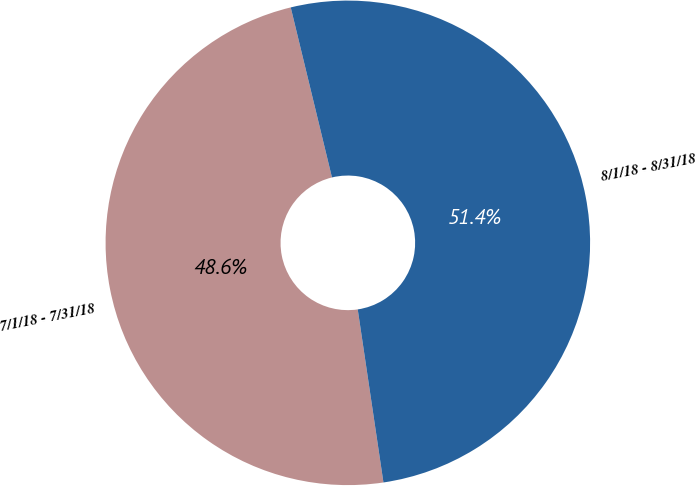<chart> <loc_0><loc_0><loc_500><loc_500><pie_chart><fcel>7/1/18 - 7/31/18<fcel>8/1/18 - 8/31/18<nl><fcel>48.56%<fcel>51.44%<nl></chart> 